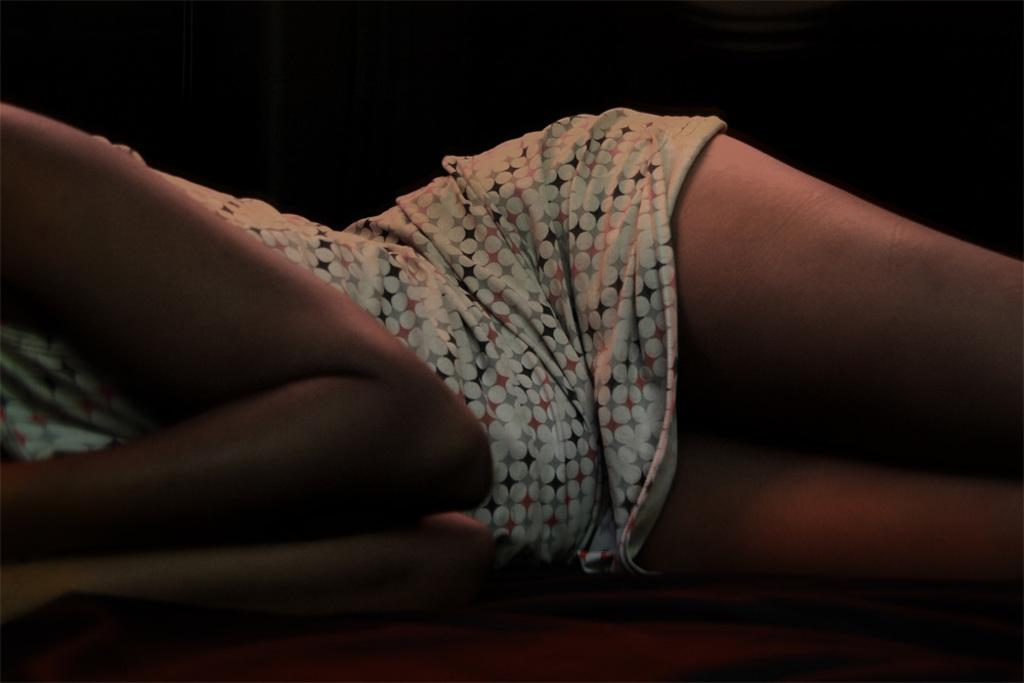What is the main subject of the image? There is a person in the image. What is the person doing in the image? The person is lying on a bed. What type of gold jewelry is the person wearing in the image? There is no mention of gold jewelry or any jewelry in the image; the person is simply lying on a bed. Can you see any snails on the bed in the image? There are no snails present in the image; the image only features a person lying on a bed. 